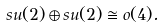Convert formula to latex. <formula><loc_0><loc_0><loc_500><loc_500>s u ( 2 ) \oplus s u ( 2 ) \cong o ( 4 ) .</formula> 